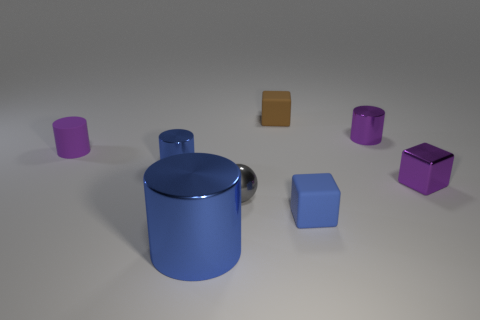What number of matte things are big blue cylinders or gray spheres?
Provide a short and direct response. 0. What is the size of the blue matte cube that is on the right side of the brown cube?
Make the answer very short. Small. What size is the blue block that is the same material as the tiny brown object?
Provide a short and direct response. Small. How many small metal objects have the same color as the matte cylinder?
Offer a very short reply. 2. Are any blue shiny cylinders visible?
Your answer should be compact. Yes. There is a tiny purple matte object; is its shape the same as the tiny purple metallic object that is in front of the tiny blue cylinder?
Make the answer very short. No. The cylinder behind the cylinder to the left of the blue shiny thing that is behind the tiny metallic block is what color?
Your answer should be compact. Purple. There is a gray shiny sphere; are there any small spheres left of it?
Offer a terse response. No. What size is the matte thing that is the same color as the large metal thing?
Give a very brief answer. Small. Are there any blue cylinders made of the same material as the large thing?
Ensure brevity in your answer.  Yes. 